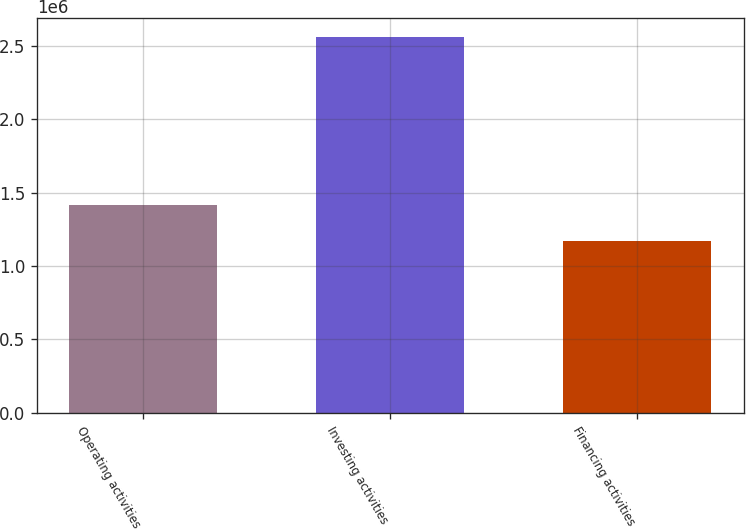<chart> <loc_0><loc_0><loc_500><loc_500><bar_chart><fcel>Operating activities<fcel>Investing activities<fcel>Financing activities<nl><fcel>1.41439e+06<fcel>2.55838e+06<fcel>1.17037e+06<nl></chart> 